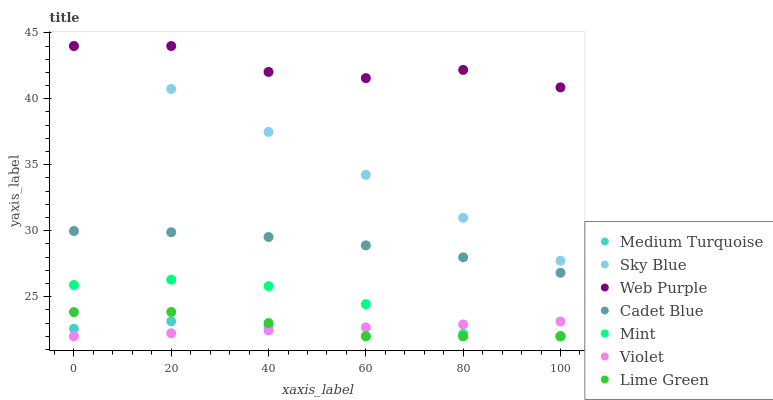Does Medium Turquoise have the minimum area under the curve?
Answer yes or no. Yes. Does Web Purple have the maximum area under the curve?
Answer yes or no. Yes. Does Lime Green have the minimum area under the curve?
Answer yes or no. No. Does Lime Green have the maximum area under the curve?
Answer yes or no. No. Is Violet the smoothest?
Answer yes or no. Yes. Is Web Purple the roughest?
Answer yes or no. Yes. Is Lime Green the smoothest?
Answer yes or no. No. Is Lime Green the roughest?
Answer yes or no. No. Does Lime Green have the lowest value?
Answer yes or no. Yes. Does Web Purple have the lowest value?
Answer yes or no. No. Does Sky Blue have the highest value?
Answer yes or no. Yes. Does Lime Green have the highest value?
Answer yes or no. No. Is Lime Green less than Cadet Blue?
Answer yes or no. Yes. Is Web Purple greater than Violet?
Answer yes or no. Yes. Does Lime Green intersect Medium Turquoise?
Answer yes or no. Yes. Is Lime Green less than Medium Turquoise?
Answer yes or no. No. Is Lime Green greater than Medium Turquoise?
Answer yes or no. No. Does Lime Green intersect Cadet Blue?
Answer yes or no. No. 